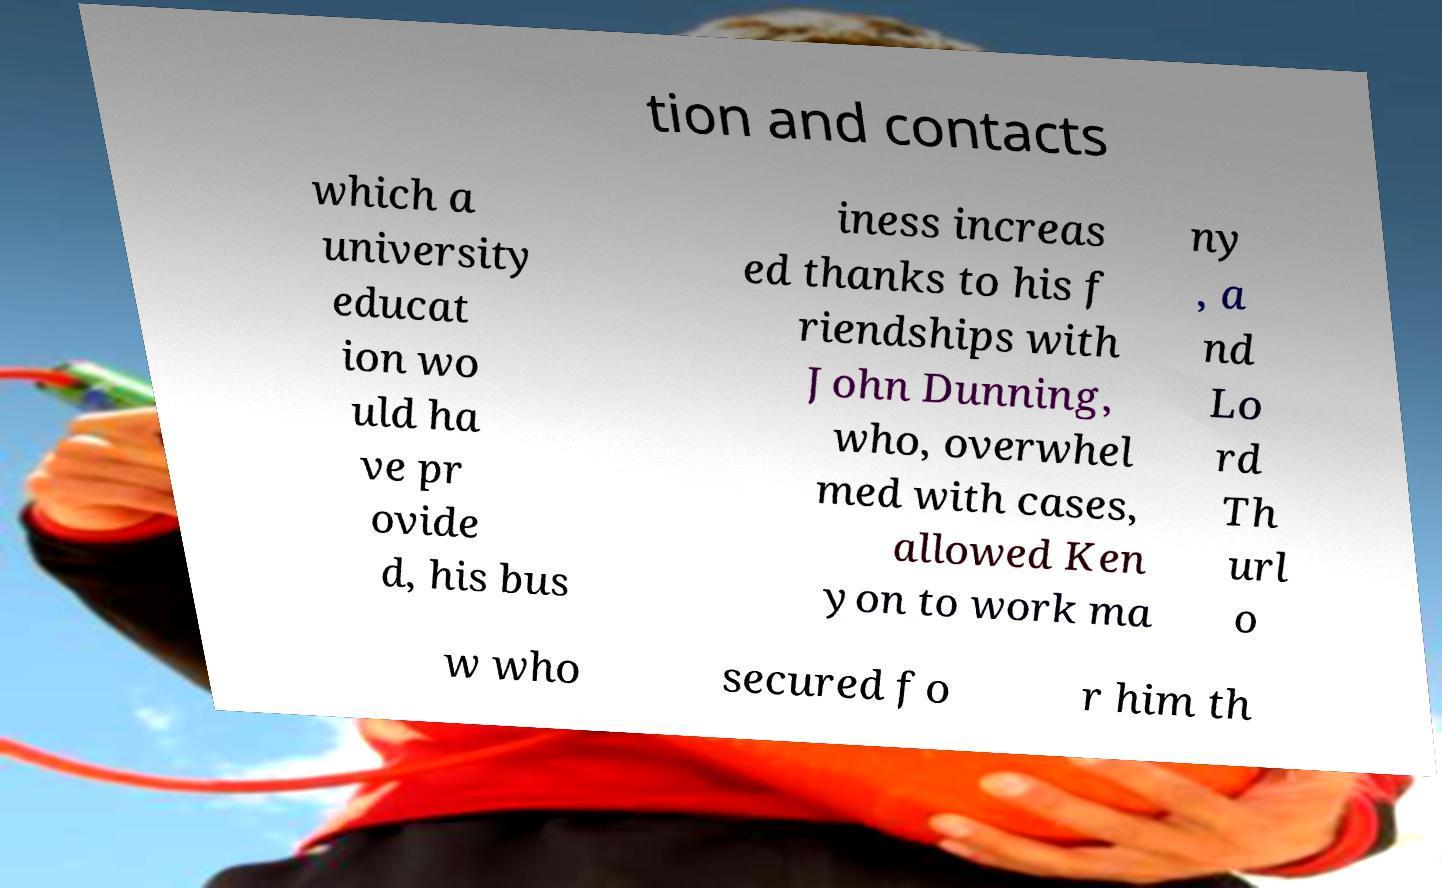Can you read and provide the text displayed in the image?This photo seems to have some interesting text. Can you extract and type it out for me? tion and contacts which a university educat ion wo uld ha ve pr ovide d, his bus iness increas ed thanks to his f riendships with John Dunning, who, overwhel med with cases, allowed Ken yon to work ma ny , a nd Lo rd Th url o w who secured fo r him th 